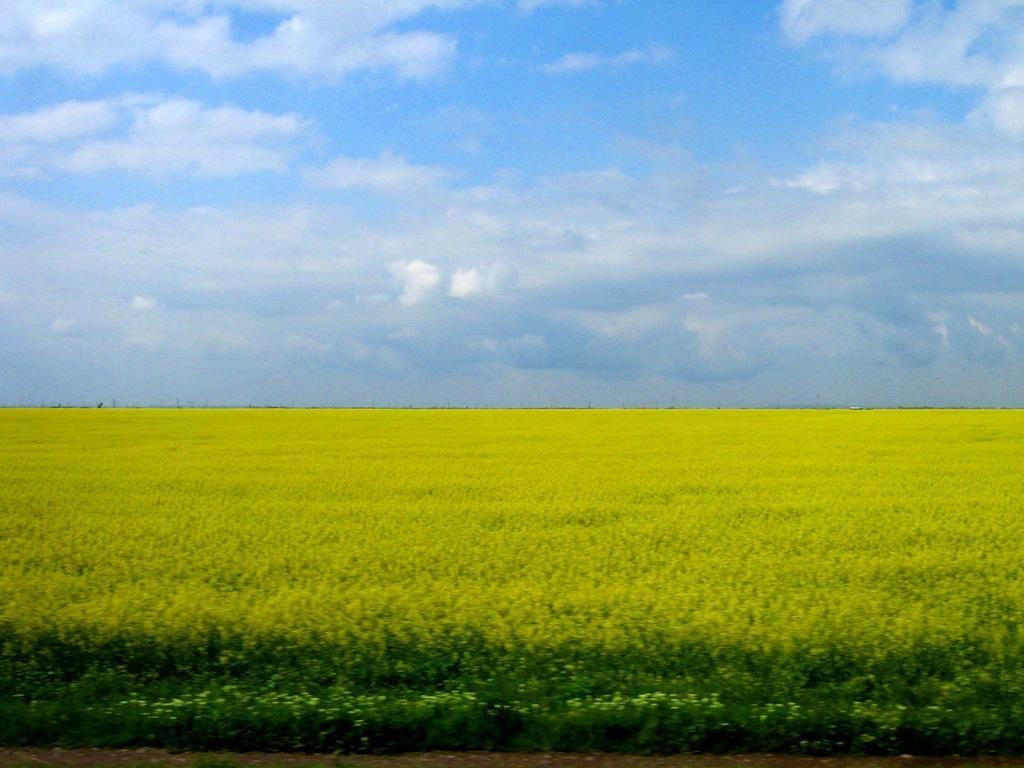Please provide a concise description of this image. At the bottom of this image there is a field. At the top of the image, I can see the sky and clouds. 